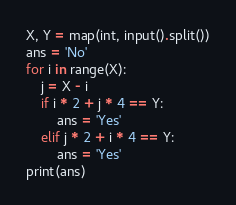<code> <loc_0><loc_0><loc_500><loc_500><_Python_>X, Y = map(int, input().split())
ans = 'No'
for i in range(X):
    j = X - i 
    if i * 2 + j * 4 == Y:
        ans = 'Yes'
    elif j * 2 + i * 4 == Y:
        ans = 'Yes'
print(ans)</code> 